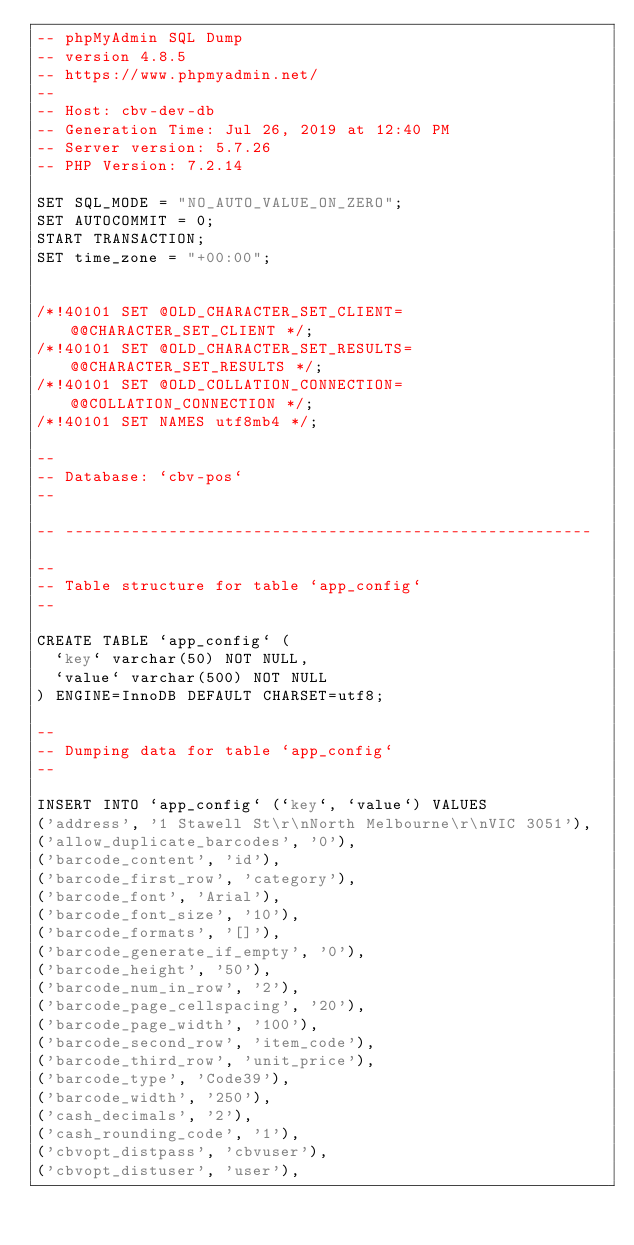Convert code to text. <code><loc_0><loc_0><loc_500><loc_500><_SQL_>-- phpMyAdmin SQL Dump
-- version 4.8.5
-- https://www.phpmyadmin.net/
--
-- Host: cbv-dev-db
-- Generation Time: Jul 26, 2019 at 12:40 PM
-- Server version: 5.7.26
-- PHP Version: 7.2.14

SET SQL_MODE = "NO_AUTO_VALUE_ON_ZERO";
SET AUTOCOMMIT = 0;
START TRANSACTION;
SET time_zone = "+00:00";


/*!40101 SET @OLD_CHARACTER_SET_CLIENT=@@CHARACTER_SET_CLIENT */;
/*!40101 SET @OLD_CHARACTER_SET_RESULTS=@@CHARACTER_SET_RESULTS */;
/*!40101 SET @OLD_COLLATION_CONNECTION=@@COLLATION_CONNECTION */;
/*!40101 SET NAMES utf8mb4 */;

--
-- Database: `cbv-pos`
--

-- --------------------------------------------------------

--
-- Table structure for table `app_config`
--

CREATE TABLE `app_config` (
  `key` varchar(50) NOT NULL,
  `value` varchar(500) NOT NULL
) ENGINE=InnoDB DEFAULT CHARSET=utf8;

--
-- Dumping data for table `app_config`
--

INSERT INTO `app_config` (`key`, `value`) VALUES
('address', '1 Stawell St\r\nNorth Melbourne\r\nVIC 3051'),
('allow_duplicate_barcodes', '0'),
('barcode_content', 'id'),
('barcode_first_row', 'category'),
('barcode_font', 'Arial'),
('barcode_font_size', '10'),
('barcode_formats', '[]'),
('barcode_generate_if_empty', '0'),
('barcode_height', '50'),
('barcode_num_in_row', '2'),
('barcode_page_cellspacing', '20'),
('barcode_page_width', '100'),
('barcode_second_row', 'item_code'),
('barcode_third_row', 'unit_price'),
('barcode_type', 'Code39'),
('barcode_width', '250'),
('cash_decimals', '2'),
('cash_rounding_code', '1'),
('cbvopt_distpass', 'cbvuser'),
('cbvopt_distuser', 'user'),</code> 